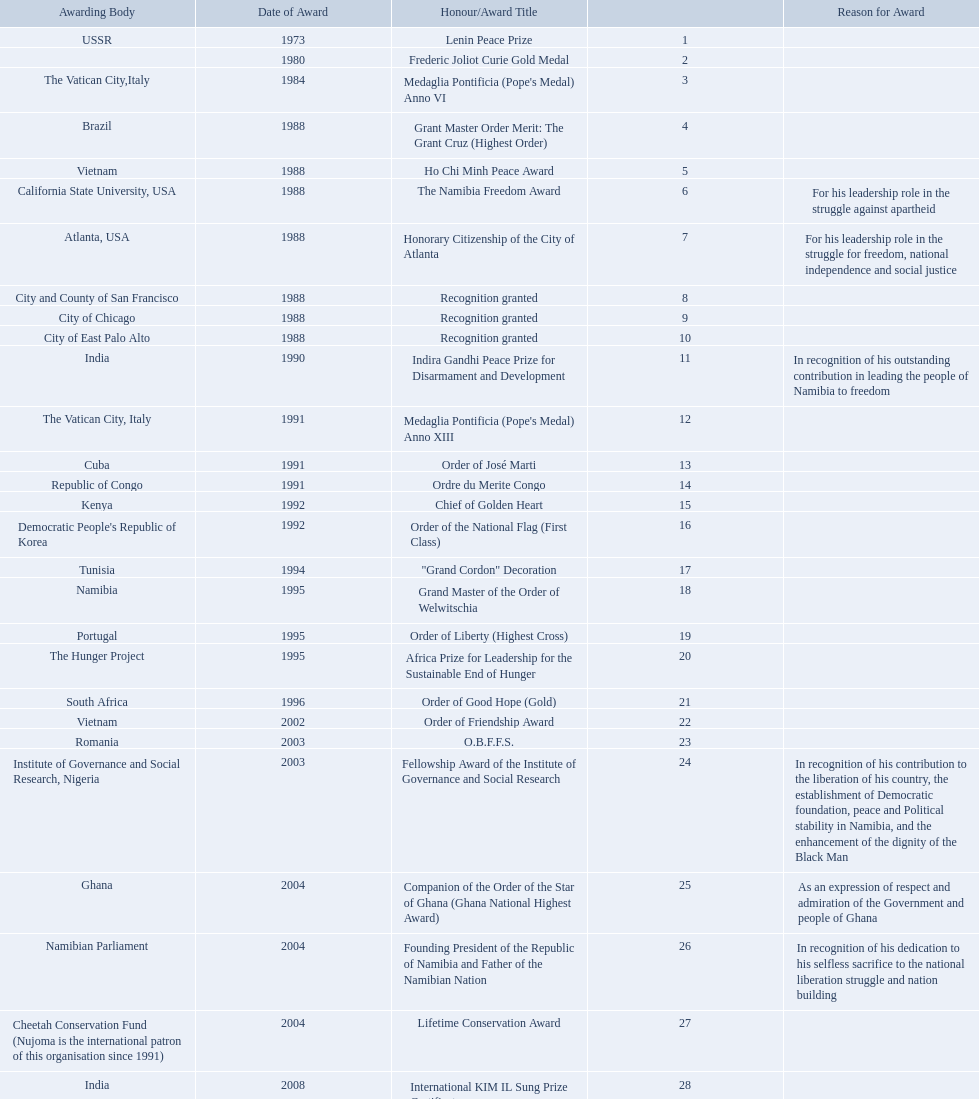What were the total number of honors/award titles listed according to this chart? 29. 